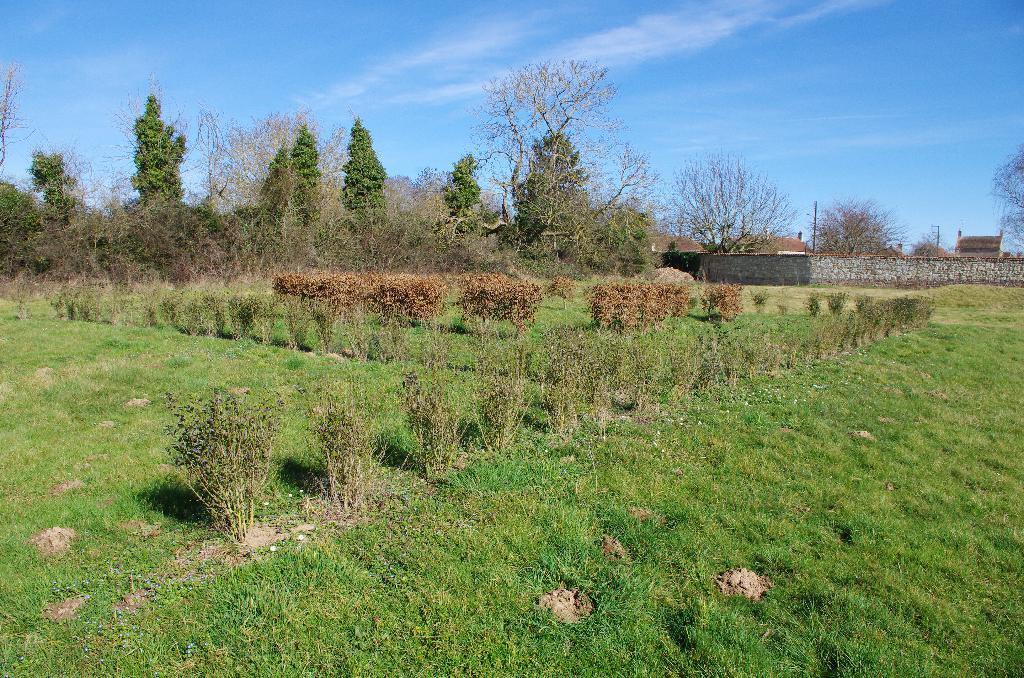In one or two sentences, can you explain what this image depicts? In this picture I can see in the middle there are plants, in the background there are trees. On the right side there is a wall, at the top there is the sky. 